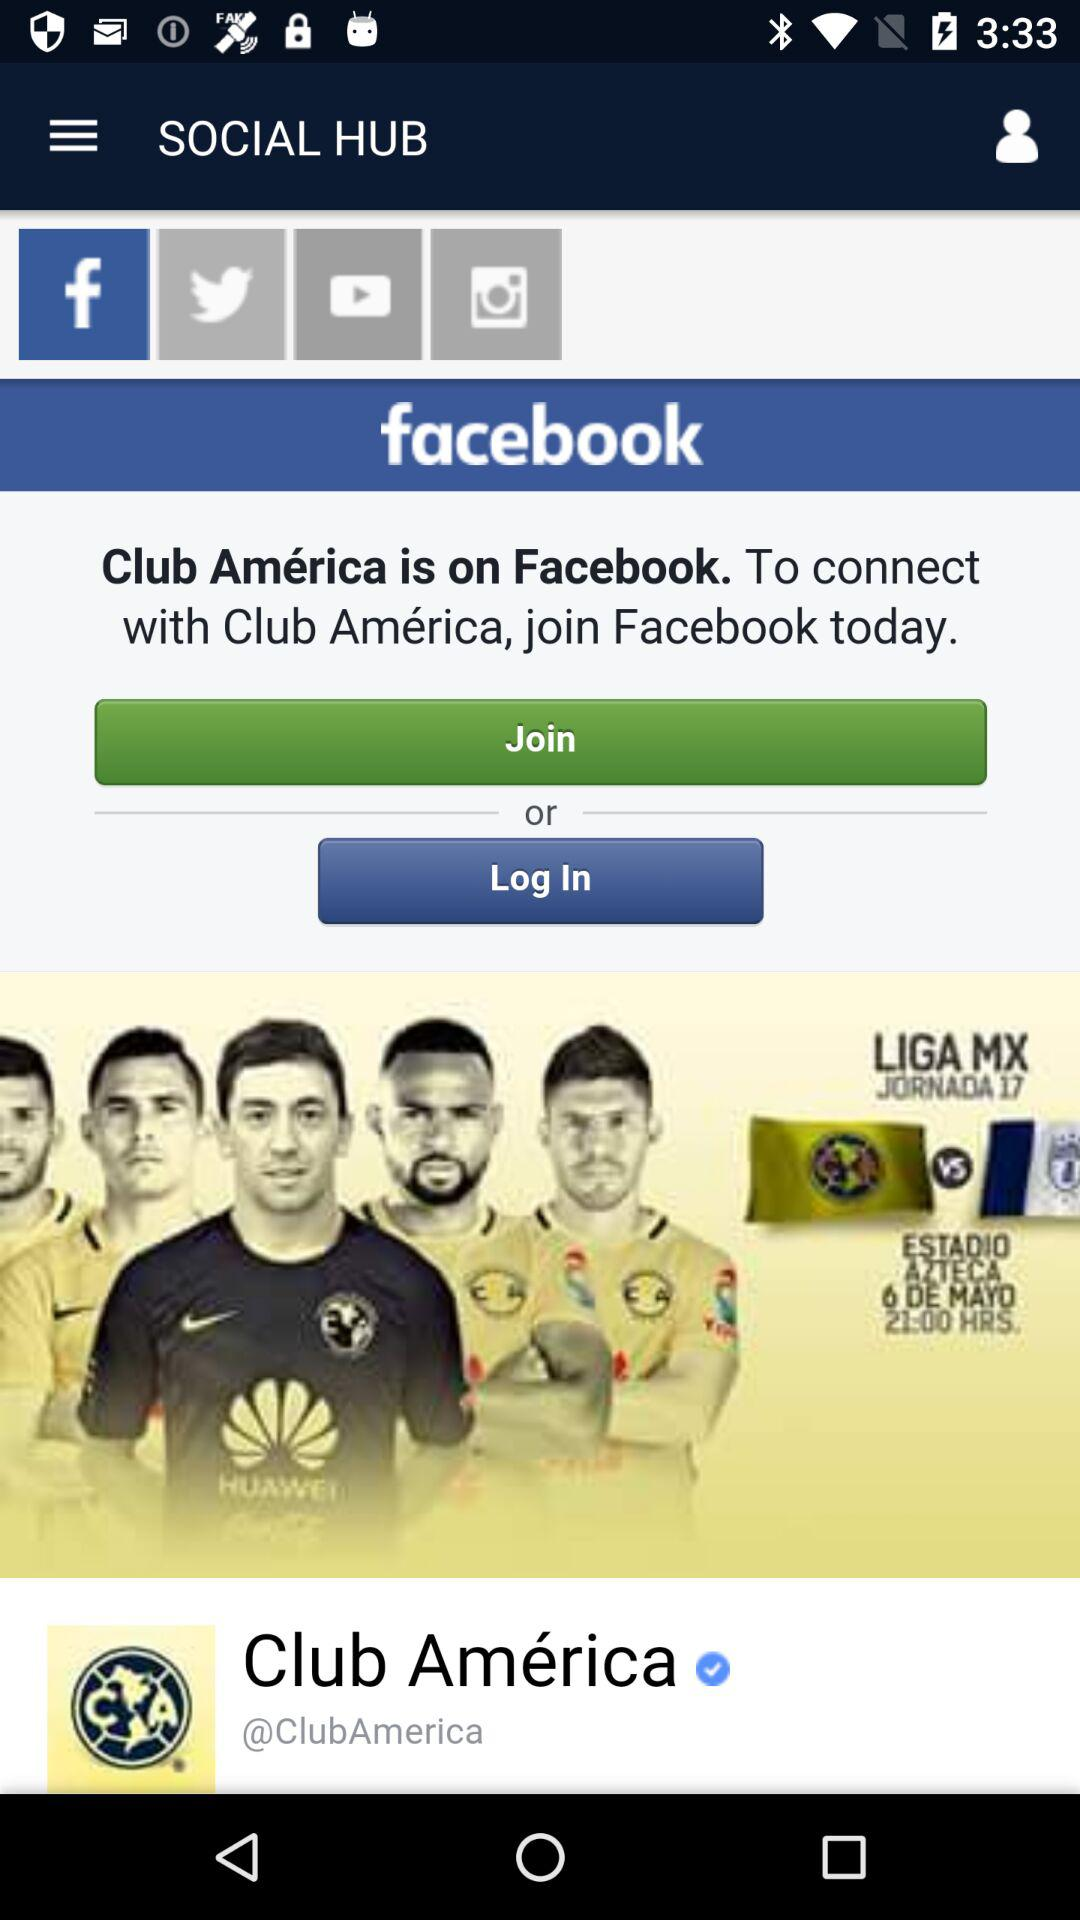By which app can we log in? You can log in with "facebook". 